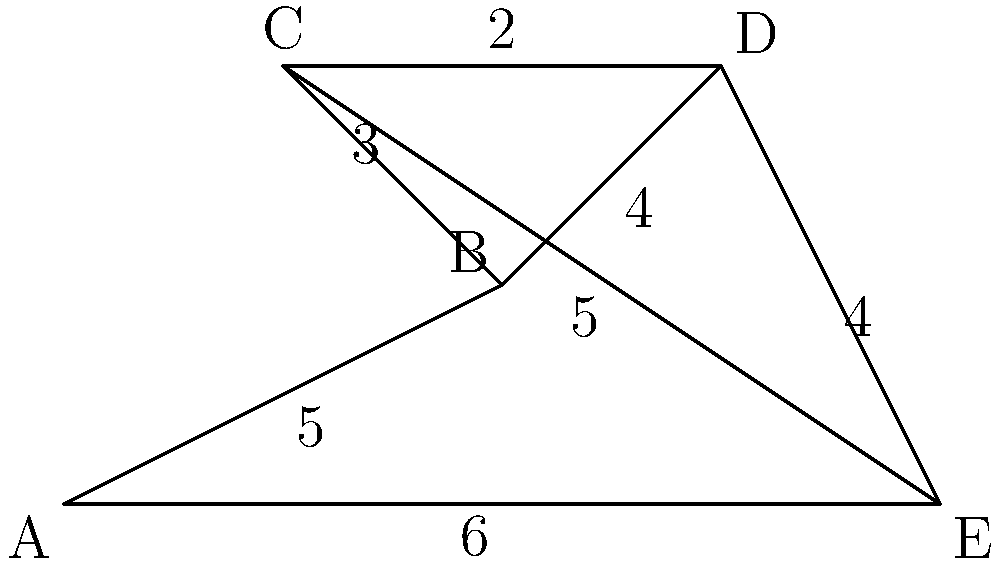Given the logistics network diagram representing supply routes between different bases, what is the minimum total distance required to connect all bases while ensuring a path exists between any two bases? To find the minimum total distance required to connect all bases while ensuring a path exists between any two bases, we need to find the Minimum Spanning Tree (MST) of the given network. We can use Kruskal's algorithm to solve this problem:

1. Sort all edges by weight in ascending order:
   (C,D): 2
   (B,C): 3
   (B,D): 4
   (D,E): 4
   (A,B): 5
   (C,E): 5
   (E,A): 6

2. Start with an empty set of edges and add edges one by one:
   a. Add (C,D): 2
   b. Add (B,C): 3
   c. Add (B,D): 4 (skip as it creates a cycle)
   d. Add (D,E): 4
   e. Add (A,B): 5

3. At this point, all bases are connected, and we have a minimum spanning tree.

4. Calculate the total distance:
   2 + 3 + 4 + 5 = 14

Therefore, the minimum total distance required to connect all bases while ensuring a path exists between any two bases is 14 units.
Answer: 14 units 